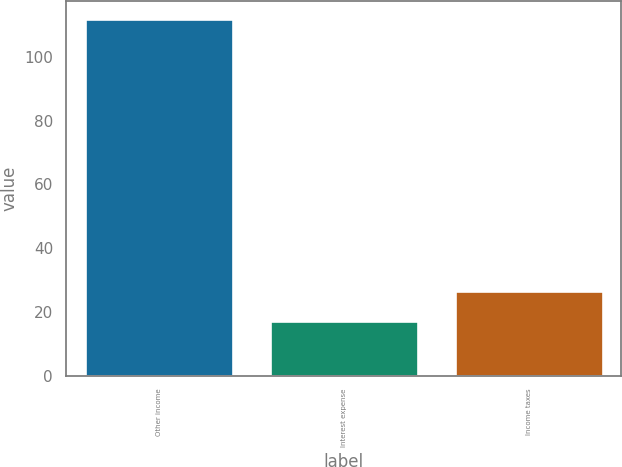<chart> <loc_0><loc_0><loc_500><loc_500><bar_chart><fcel>Other income<fcel>Interest expense<fcel>Income taxes<nl><fcel>112<fcel>17<fcel>26.5<nl></chart> 